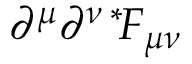Convert formula to latex. <formula><loc_0><loc_0><loc_500><loc_500>\partial ^ { \mu } \partial ^ { \nu \, * \, } F _ { \mu \nu }</formula> 